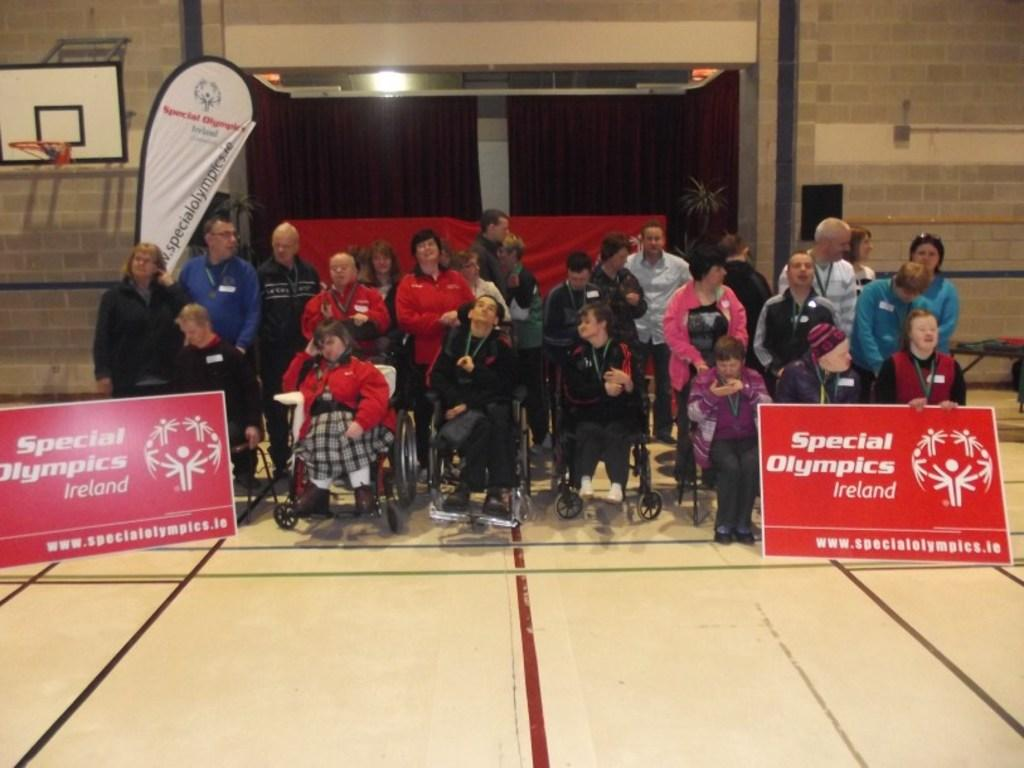What are the people in the image using for mobility? The people in the image are sitting in wheelchairs for mobility. Are there any people standing in the image? Yes, some people are standing in the image. What can be seen on the boards in the image? The facts do not specify what is on the boards, so we cannot answer that question definitively. What is visible in the background of the image? In the background of the image, there are curtains, light, a hoop, and a wall. What type of cracker is being passed around in the image? There is no cracker present in the image, so we cannot answer that question definitively. 